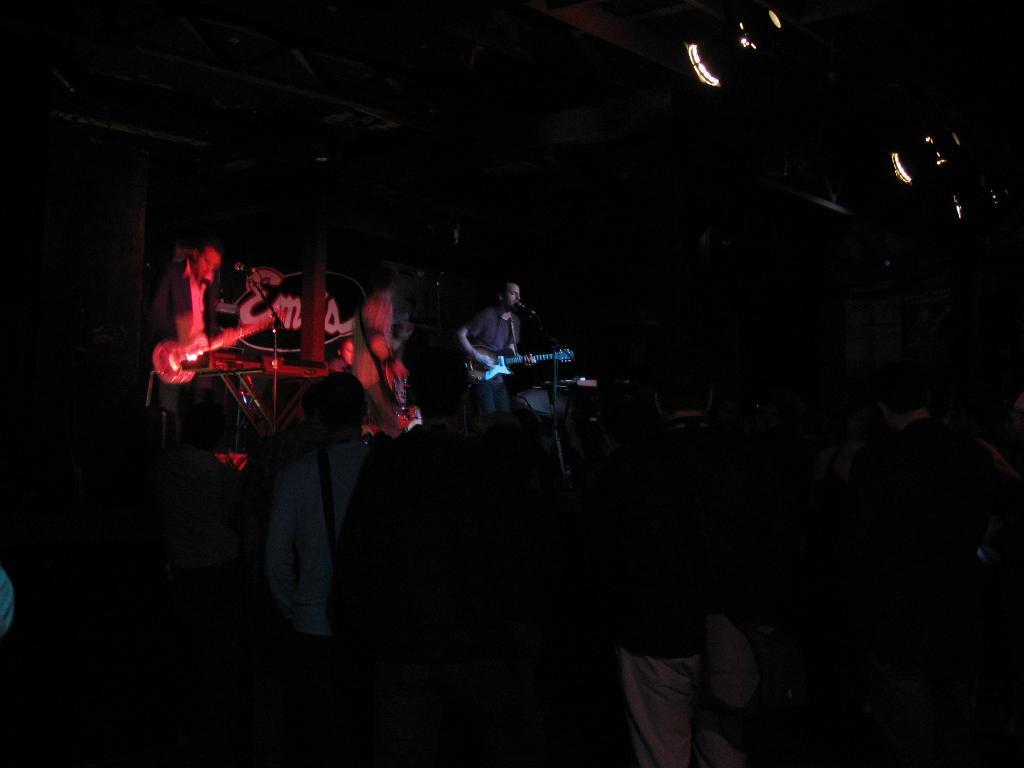In one or two sentences, can you explain what this image depicts? In this image I can see group of people standing. In front of them there are people holding the musical instruments and standing front of the mic. 